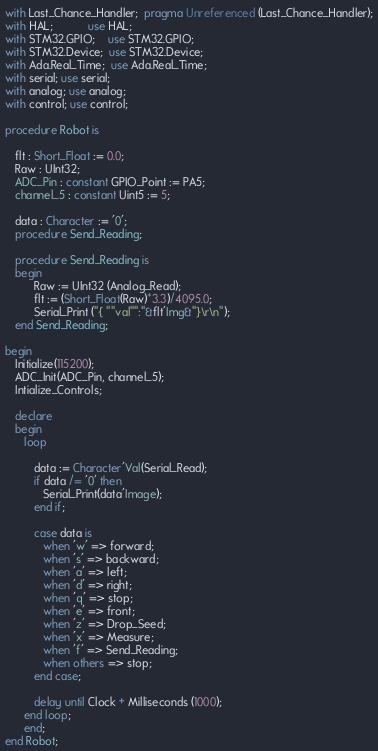Convert code to text. <code><loc_0><loc_0><loc_500><loc_500><_Ada_>with Last_Chance_Handler;  pragma Unreferenced (Last_Chance_Handler);
with HAL;           use HAL;
with STM32.GPIO;    use STM32.GPIO;
with STM32.Device;  use STM32.Device;
with Ada.Real_Time;  use Ada.Real_Time;
with serial; use serial;
with analog; use analog;
with control; use control;

procedure Robot is

   flt : Short_Float := 0.0;
   Raw : UInt32;
   ADC_Pin : constant GPIO_Point := PA5;
   channel_5 : constant Uint5 := 5;

   data : Character := '0';
   procedure Send_Reading;

   procedure Send_Reading is
   begin
         Raw := UInt32 (Analog_Read);
         flt := (Short_Float(Raw)*3.3)/4095.0;
         Serial_Print ("{ ""val"":"&flt'Img&"}\r\n");
   end Send_Reading;

begin
   Initialize(115200);
   ADC_Init(ADC_Pin, channel_5);
   Intialize_Controls;

   declare
   begin
      loop

         data := Character'Val(Serial_Read);
         if data /= '0' then
            Serial_Print(data'Image);
         end if;

         case data is
            when 'w' => forward;
            when 's' => backward;
            when 'a' => left;
            when 'd' => right;
            when 'q' => stop;
            when 'e' => front;
            when 'z' => Drop_Seed;
            when 'x' => Measure;
            when 'f' => Send_Reading;
            when others => stop;
         end case;

         delay until Clock + Milliseconds (1000);
      end loop;
      end;
end Robot;
</code> 